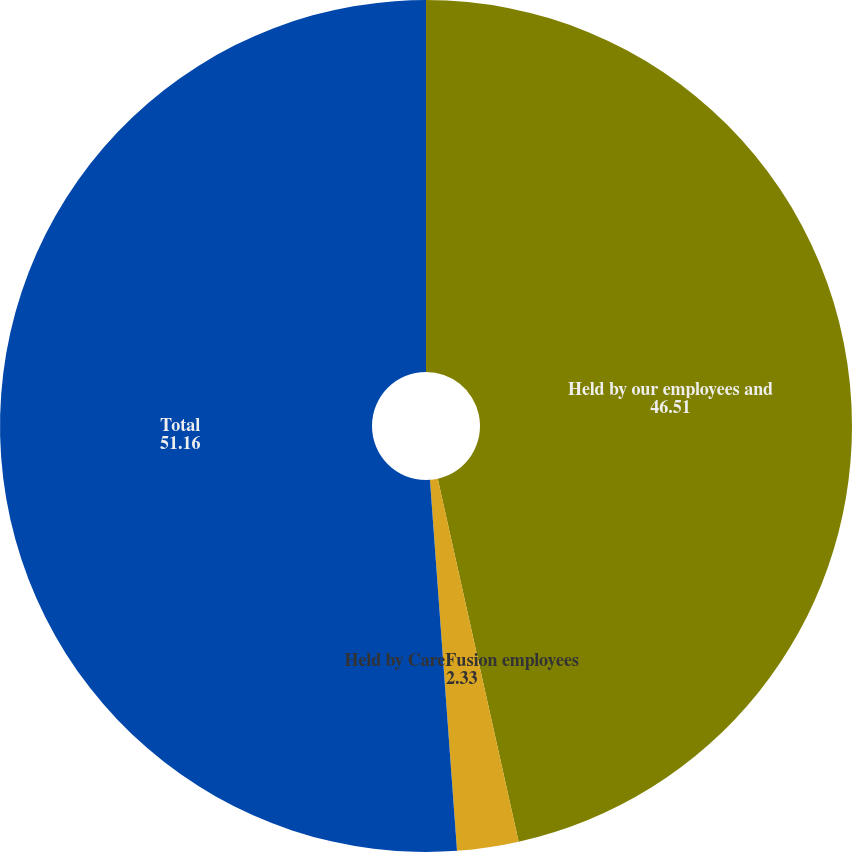<chart> <loc_0><loc_0><loc_500><loc_500><pie_chart><fcel>Held by our employees and<fcel>Held by CareFusion employees<fcel>Total<nl><fcel>46.51%<fcel>2.33%<fcel>51.16%<nl></chart> 